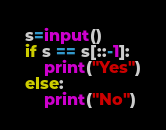<code> <loc_0><loc_0><loc_500><loc_500><_Python_>s=input()
if s == s[::-1]:
    print("Yes")
else:
    print("No")</code> 